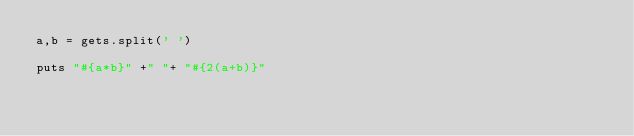Convert code to text. <code><loc_0><loc_0><loc_500><loc_500><_Ruby_>a,b = gets.split(' ')

puts "#{a*b}" +" "+ "#{2(a+b)}"
</code> 